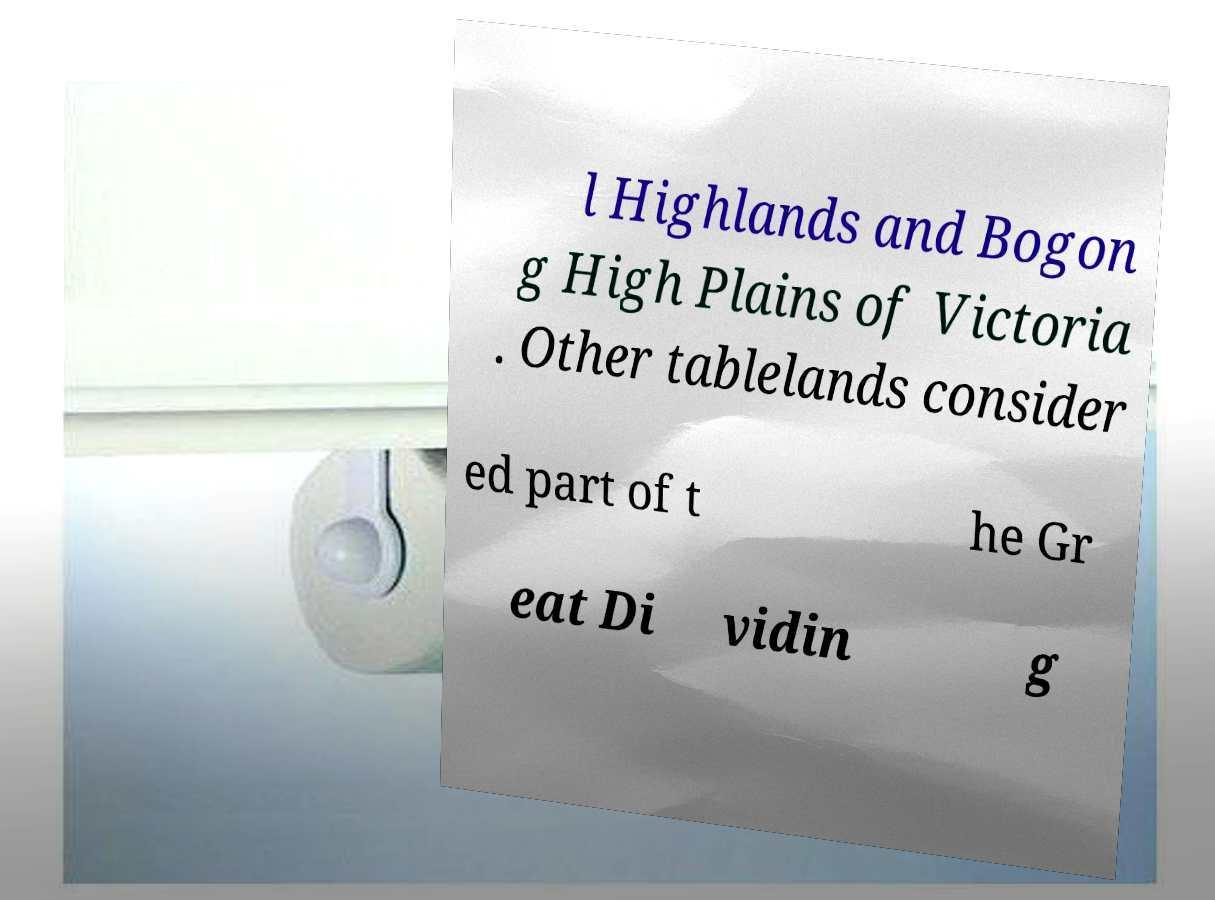I need the written content from this picture converted into text. Can you do that? l Highlands and Bogon g High Plains of Victoria . Other tablelands consider ed part of t he Gr eat Di vidin g 